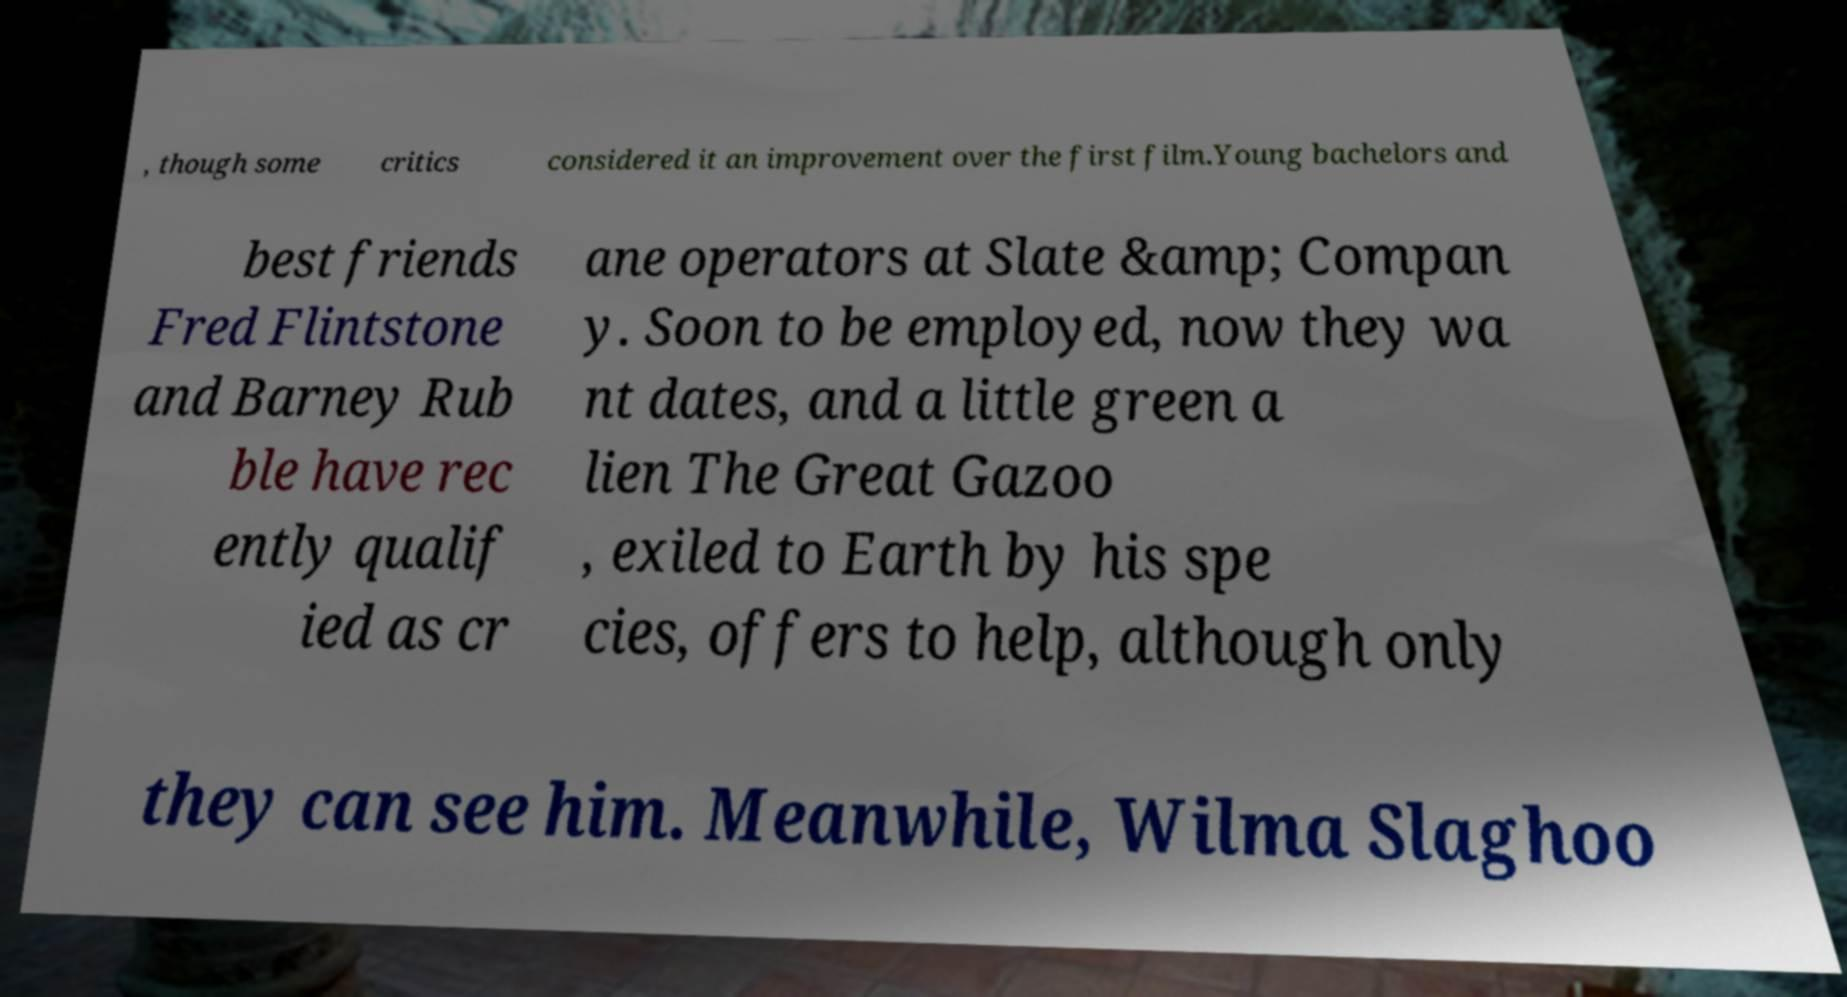Can you read and provide the text displayed in the image?This photo seems to have some interesting text. Can you extract and type it out for me? , though some critics considered it an improvement over the first film.Young bachelors and best friends Fred Flintstone and Barney Rub ble have rec ently qualif ied as cr ane operators at Slate &amp; Compan y. Soon to be employed, now they wa nt dates, and a little green a lien The Great Gazoo , exiled to Earth by his spe cies, offers to help, although only they can see him. Meanwhile, Wilma Slaghoo 